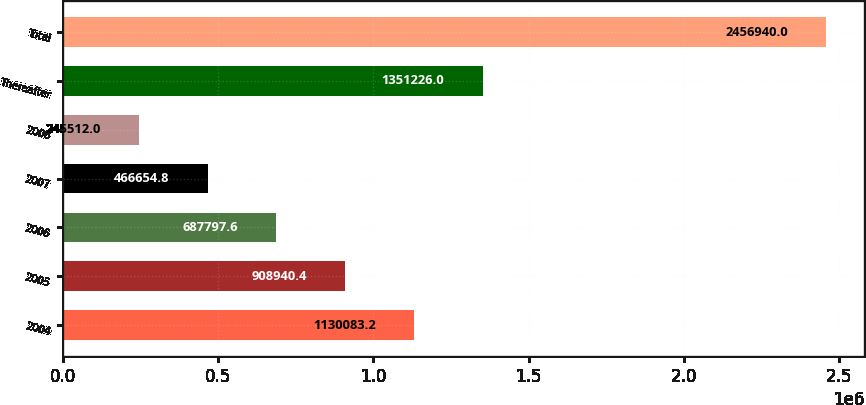<chart> <loc_0><loc_0><loc_500><loc_500><bar_chart><fcel>2004<fcel>2005<fcel>2006<fcel>2007<fcel>2008<fcel>Thereafter<fcel>Total<nl><fcel>1.13008e+06<fcel>908940<fcel>687798<fcel>466655<fcel>245512<fcel>1.35123e+06<fcel>2.45694e+06<nl></chart> 